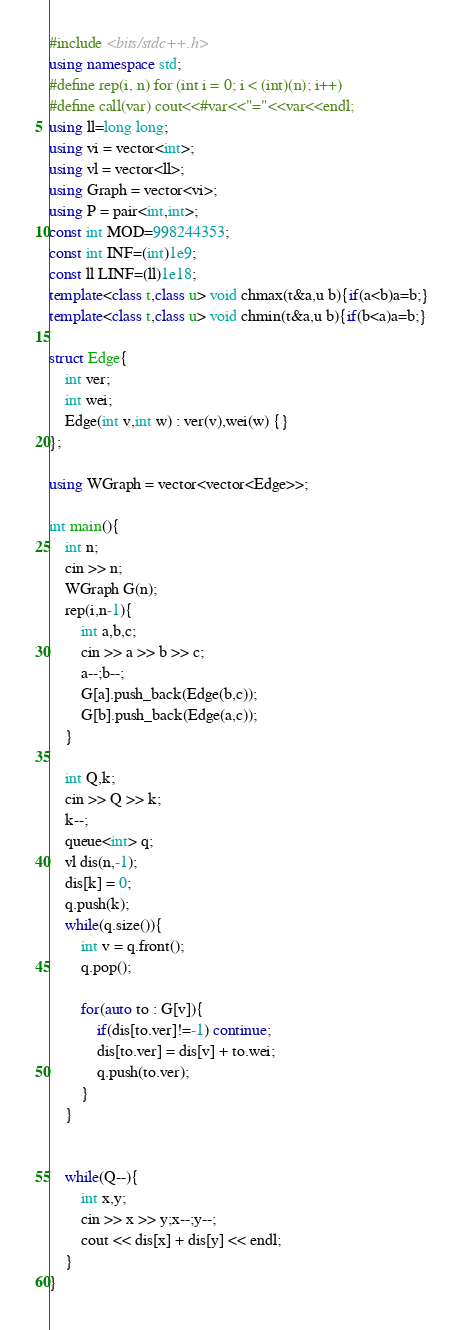Convert code to text. <code><loc_0><loc_0><loc_500><loc_500><_C++_>#include <bits/stdc++.h>
using namespace std;
#define rep(i, n) for (int i = 0; i < (int)(n); i++)
#define call(var) cout<<#var<<"="<<var<<endl;
using ll=long long;
using vi = vector<int>;
using vl = vector<ll>;
using Graph = vector<vi>;
using P = pair<int,int>;
const int MOD=998244353;
const int INF=(int)1e9;
const ll LINF=(ll)1e18;
template<class t,class u> void chmax(t&a,u b){if(a<b)a=b;}
template<class t,class u> void chmin(t&a,u b){if(b<a)a=b;}

struct Edge{
    int ver;
    int wei;
    Edge(int v,int w) : ver(v),wei(w) {}
};

using WGraph = vector<vector<Edge>>;

int main(){
    int n;
    cin >> n;
    WGraph G(n);
    rep(i,n-1){
        int a,b,c;
        cin >> a >> b >> c;
        a--;b--;
        G[a].push_back(Edge(b,c));
        G[b].push_back(Edge(a,c));
    }

    int Q,k;
    cin >> Q >> k;
    k--;
    queue<int> q;
    vl dis(n,-1);
    dis[k] = 0;
    q.push(k);
    while(q.size()){
        int v = q.front();
        q.pop();

        for(auto to : G[v]){
            if(dis[to.ver]!=-1) continue;
            dis[to.ver] = dis[v] + to.wei;
            q.push(to.ver);
        }
    }


    while(Q--){
        int x,y;
        cin >> x >> y;x--;y--;
        cout << dis[x] + dis[y] << endl;
    }
}</code> 